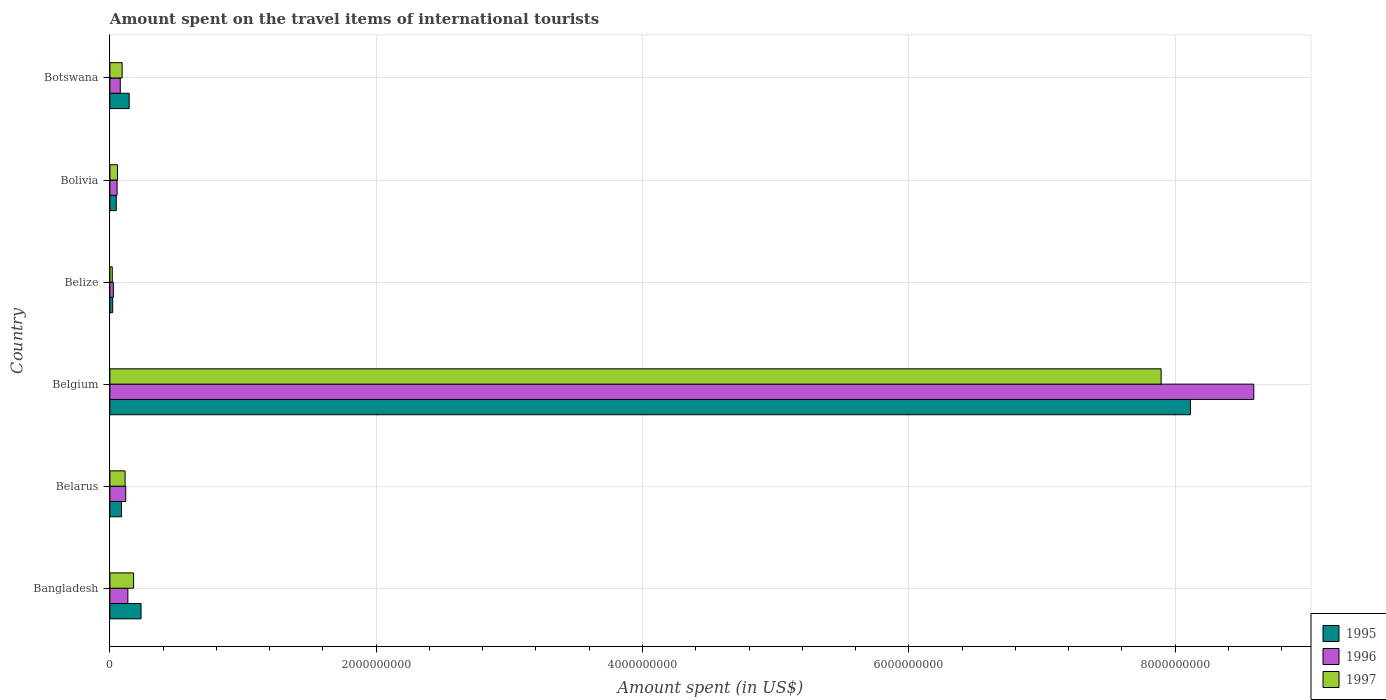How many groups of bars are there?
Your answer should be compact. 6. How many bars are there on the 3rd tick from the bottom?
Make the answer very short. 3. What is the amount spent on the travel items of international tourists in 1996 in Bangladesh?
Provide a succinct answer. 1.35e+08. Across all countries, what is the maximum amount spent on the travel items of international tourists in 1996?
Offer a terse response. 8.59e+09. Across all countries, what is the minimum amount spent on the travel items of international tourists in 1995?
Offer a very short reply. 2.10e+07. In which country was the amount spent on the travel items of international tourists in 1995 minimum?
Keep it short and to the point. Belize. What is the total amount spent on the travel items of international tourists in 1996 in the graph?
Keep it short and to the point. 9.00e+09. What is the difference between the amount spent on the travel items of international tourists in 1995 in Bangladesh and that in Botswana?
Your response must be concise. 8.90e+07. What is the difference between the amount spent on the travel items of international tourists in 1996 in Bangladesh and the amount spent on the travel items of international tourists in 1995 in Belarus?
Give a very brief answer. 4.80e+07. What is the average amount spent on the travel items of international tourists in 1996 per country?
Your response must be concise. 1.50e+09. What is the difference between the amount spent on the travel items of international tourists in 1997 and amount spent on the travel items of international tourists in 1996 in Bangladesh?
Ensure brevity in your answer.  4.30e+07. In how many countries, is the amount spent on the travel items of international tourists in 1996 greater than 5200000000 US$?
Your answer should be very brief. 1. What is the ratio of the amount spent on the travel items of international tourists in 1997 in Belarus to that in Botswana?
Give a very brief answer. 1.24. Is the amount spent on the travel items of international tourists in 1997 in Belarus less than that in Botswana?
Ensure brevity in your answer.  No. What is the difference between the highest and the second highest amount spent on the travel items of international tourists in 1995?
Give a very brief answer. 7.88e+09. What is the difference between the highest and the lowest amount spent on the travel items of international tourists in 1995?
Your response must be concise. 8.09e+09. Is it the case that in every country, the sum of the amount spent on the travel items of international tourists in 1996 and amount spent on the travel items of international tourists in 1997 is greater than the amount spent on the travel items of international tourists in 1995?
Your answer should be compact. Yes. Are the values on the major ticks of X-axis written in scientific E-notation?
Offer a terse response. No. How many legend labels are there?
Keep it short and to the point. 3. What is the title of the graph?
Your answer should be compact. Amount spent on the travel items of international tourists. Does "1971" appear as one of the legend labels in the graph?
Your answer should be compact. No. What is the label or title of the X-axis?
Your answer should be very brief. Amount spent (in US$). What is the Amount spent (in US$) in 1995 in Bangladesh?
Your response must be concise. 2.34e+08. What is the Amount spent (in US$) in 1996 in Bangladesh?
Provide a short and direct response. 1.35e+08. What is the Amount spent (in US$) of 1997 in Bangladesh?
Offer a very short reply. 1.78e+08. What is the Amount spent (in US$) in 1995 in Belarus?
Make the answer very short. 8.70e+07. What is the Amount spent (in US$) of 1996 in Belarus?
Offer a terse response. 1.19e+08. What is the Amount spent (in US$) in 1997 in Belarus?
Make the answer very short. 1.14e+08. What is the Amount spent (in US$) in 1995 in Belgium?
Your answer should be very brief. 8.12e+09. What is the Amount spent (in US$) of 1996 in Belgium?
Your answer should be compact. 8.59e+09. What is the Amount spent (in US$) in 1997 in Belgium?
Provide a short and direct response. 7.90e+09. What is the Amount spent (in US$) in 1995 in Belize?
Make the answer very short. 2.10e+07. What is the Amount spent (in US$) of 1996 in Belize?
Your answer should be very brief. 2.60e+07. What is the Amount spent (in US$) in 1997 in Belize?
Your response must be concise. 1.80e+07. What is the Amount spent (in US$) in 1995 in Bolivia?
Offer a very short reply. 4.80e+07. What is the Amount spent (in US$) of 1996 in Bolivia?
Offer a very short reply. 5.40e+07. What is the Amount spent (in US$) of 1997 in Bolivia?
Your answer should be very brief. 5.70e+07. What is the Amount spent (in US$) in 1995 in Botswana?
Offer a terse response. 1.45e+08. What is the Amount spent (in US$) in 1996 in Botswana?
Give a very brief answer. 7.80e+07. What is the Amount spent (in US$) of 1997 in Botswana?
Your answer should be very brief. 9.20e+07. Across all countries, what is the maximum Amount spent (in US$) of 1995?
Your answer should be compact. 8.12e+09. Across all countries, what is the maximum Amount spent (in US$) of 1996?
Ensure brevity in your answer.  8.59e+09. Across all countries, what is the maximum Amount spent (in US$) of 1997?
Offer a terse response. 7.90e+09. Across all countries, what is the minimum Amount spent (in US$) of 1995?
Make the answer very short. 2.10e+07. Across all countries, what is the minimum Amount spent (in US$) in 1996?
Make the answer very short. 2.60e+07. Across all countries, what is the minimum Amount spent (in US$) in 1997?
Ensure brevity in your answer.  1.80e+07. What is the total Amount spent (in US$) in 1995 in the graph?
Provide a short and direct response. 8.65e+09. What is the total Amount spent (in US$) in 1996 in the graph?
Offer a terse response. 9.00e+09. What is the total Amount spent (in US$) of 1997 in the graph?
Your answer should be very brief. 8.35e+09. What is the difference between the Amount spent (in US$) of 1995 in Bangladesh and that in Belarus?
Give a very brief answer. 1.47e+08. What is the difference between the Amount spent (in US$) in 1996 in Bangladesh and that in Belarus?
Provide a short and direct response. 1.60e+07. What is the difference between the Amount spent (in US$) in 1997 in Bangladesh and that in Belarus?
Make the answer very short. 6.40e+07. What is the difference between the Amount spent (in US$) of 1995 in Bangladesh and that in Belgium?
Your answer should be very brief. -7.88e+09. What is the difference between the Amount spent (in US$) in 1996 in Bangladesh and that in Belgium?
Offer a terse response. -8.46e+09. What is the difference between the Amount spent (in US$) in 1997 in Bangladesh and that in Belgium?
Ensure brevity in your answer.  -7.72e+09. What is the difference between the Amount spent (in US$) of 1995 in Bangladesh and that in Belize?
Your answer should be compact. 2.13e+08. What is the difference between the Amount spent (in US$) in 1996 in Bangladesh and that in Belize?
Your answer should be compact. 1.09e+08. What is the difference between the Amount spent (in US$) in 1997 in Bangladesh and that in Belize?
Your answer should be compact. 1.60e+08. What is the difference between the Amount spent (in US$) of 1995 in Bangladesh and that in Bolivia?
Make the answer very short. 1.86e+08. What is the difference between the Amount spent (in US$) of 1996 in Bangladesh and that in Bolivia?
Offer a very short reply. 8.10e+07. What is the difference between the Amount spent (in US$) of 1997 in Bangladesh and that in Bolivia?
Keep it short and to the point. 1.21e+08. What is the difference between the Amount spent (in US$) in 1995 in Bangladesh and that in Botswana?
Your answer should be very brief. 8.90e+07. What is the difference between the Amount spent (in US$) of 1996 in Bangladesh and that in Botswana?
Give a very brief answer. 5.70e+07. What is the difference between the Amount spent (in US$) in 1997 in Bangladesh and that in Botswana?
Offer a very short reply. 8.60e+07. What is the difference between the Amount spent (in US$) of 1995 in Belarus and that in Belgium?
Offer a terse response. -8.03e+09. What is the difference between the Amount spent (in US$) in 1996 in Belarus and that in Belgium?
Provide a short and direct response. -8.47e+09. What is the difference between the Amount spent (in US$) of 1997 in Belarus and that in Belgium?
Keep it short and to the point. -7.78e+09. What is the difference between the Amount spent (in US$) of 1995 in Belarus and that in Belize?
Offer a terse response. 6.60e+07. What is the difference between the Amount spent (in US$) of 1996 in Belarus and that in Belize?
Give a very brief answer. 9.30e+07. What is the difference between the Amount spent (in US$) in 1997 in Belarus and that in Belize?
Provide a short and direct response. 9.60e+07. What is the difference between the Amount spent (in US$) in 1995 in Belarus and that in Bolivia?
Ensure brevity in your answer.  3.90e+07. What is the difference between the Amount spent (in US$) in 1996 in Belarus and that in Bolivia?
Your response must be concise. 6.50e+07. What is the difference between the Amount spent (in US$) in 1997 in Belarus and that in Bolivia?
Ensure brevity in your answer.  5.70e+07. What is the difference between the Amount spent (in US$) in 1995 in Belarus and that in Botswana?
Your answer should be compact. -5.80e+07. What is the difference between the Amount spent (in US$) in 1996 in Belarus and that in Botswana?
Your answer should be very brief. 4.10e+07. What is the difference between the Amount spent (in US$) in 1997 in Belarus and that in Botswana?
Offer a very short reply. 2.20e+07. What is the difference between the Amount spent (in US$) in 1995 in Belgium and that in Belize?
Offer a terse response. 8.09e+09. What is the difference between the Amount spent (in US$) of 1996 in Belgium and that in Belize?
Ensure brevity in your answer.  8.56e+09. What is the difference between the Amount spent (in US$) in 1997 in Belgium and that in Belize?
Your answer should be compact. 7.88e+09. What is the difference between the Amount spent (in US$) of 1995 in Belgium and that in Bolivia?
Give a very brief answer. 8.07e+09. What is the difference between the Amount spent (in US$) of 1996 in Belgium and that in Bolivia?
Keep it short and to the point. 8.54e+09. What is the difference between the Amount spent (in US$) in 1997 in Belgium and that in Bolivia?
Ensure brevity in your answer.  7.84e+09. What is the difference between the Amount spent (in US$) of 1995 in Belgium and that in Botswana?
Ensure brevity in your answer.  7.97e+09. What is the difference between the Amount spent (in US$) of 1996 in Belgium and that in Botswana?
Ensure brevity in your answer.  8.51e+09. What is the difference between the Amount spent (in US$) of 1997 in Belgium and that in Botswana?
Give a very brief answer. 7.80e+09. What is the difference between the Amount spent (in US$) of 1995 in Belize and that in Bolivia?
Offer a terse response. -2.70e+07. What is the difference between the Amount spent (in US$) in 1996 in Belize and that in Bolivia?
Keep it short and to the point. -2.80e+07. What is the difference between the Amount spent (in US$) of 1997 in Belize and that in Bolivia?
Your response must be concise. -3.90e+07. What is the difference between the Amount spent (in US$) of 1995 in Belize and that in Botswana?
Make the answer very short. -1.24e+08. What is the difference between the Amount spent (in US$) in 1996 in Belize and that in Botswana?
Offer a terse response. -5.20e+07. What is the difference between the Amount spent (in US$) of 1997 in Belize and that in Botswana?
Offer a terse response. -7.40e+07. What is the difference between the Amount spent (in US$) of 1995 in Bolivia and that in Botswana?
Offer a terse response. -9.70e+07. What is the difference between the Amount spent (in US$) of 1996 in Bolivia and that in Botswana?
Make the answer very short. -2.40e+07. What is the difference between the Amount spent (in US$) of 1997 in Bolivia and that in Botswana?
Keep it short and to the point. -3.50e+07. What is the difference between the Amount spent (in US$) of 1995 in Bangladesh and the Amount spent (in US$) of 1996 in Belarus?
Provide a succinct answer. 1.15e+08. What is the difference between the Amount spent (in US$) of 1995 in Bangladesh and the Amount spent (in US$) of 1997 in Belarus?
Make the answer very short. 1.20e+08. What is the difference between the Amount spent (in US$) of 1996 in Bangladesh and the Amount spent (in US$) of 1997 in Belarus?
Give a very brief answer. 2.10e+07. What is the difference between the Amount spent (in US$) in 1995 in Bangladesh and the Amount spent (in US$) in 1996 in Belgium?
Make the answer very short. -8.36e+09. What is the difference between the Amount spent (in US$) of 1995 in Bangladesh and the Amount spent (in US$) of 1997 in Belgium?
Your answer should be very brief. -7.66e+09. What is the difference between the Amount spent (in US$) of 1996 in Bangladesh and the Amount spent (in US$) of 1997 in Belgium?
Provide a short and direct response. -7.76e+09. What is the difference between the Amount spent (in US$) of 1995 in Bangladesh and the Amount spent (in US$) of 1996 in Belize?
Give a very brief answer. 2.08e+08. What is the difference between the Amount spent (in US$) in 1995 in Bangladesh and the Amount spent (in US$) in 1997 in Belize?
Ensure brevity in your answer.  2.16e+08. What is the difference between the Amount spent (in US$) of 1996 in Bangladesh and the Amount spent (in US$) of 1997 in Belize?
Provide a succinct answer. 1.17e+08. What is the difference between the Amount spent (in US$) in 1995 in Bangladesh and the Amount spent (in US$) in 1996 in Bolivia?
Your answer should be very brief. 1.80e+08. What is the difference between the Amount spent (in US$) of 1995 in Bangladesh and the Amount spent (in US$) of 1997 in Bolivia?
Your response must be concise. 1.77e+08. What is the difference between the Amount spent (in US$) in 1996 in Bangladesh and the Amount spent (in US$) in 1997 in Bolivia?
Ensure brevity in your answer.  7.80e+07. What is the difference between the Amount spent (in US$) in 1995 in Bangladesh and the Amount spent (in US$) in 1996 in Botswana?
Provide a short and direct response. 1.56e+08. What is the difference between the Amount spent (in US$) of 1995 in Bangladesh and the Amount spent (in US$) of 1997 in Botswana?
Provide a short and direct response. 1.42e+08. What is the difference between the Amount spent (in US$) in 1996 in Bangladesh and the Amount spent (in US$) in 1997 in Botswana?
Your answer should be compact. 4.30e+07. What is the difference between the Amount spent (in US$) of 1995 in Belarus and the Amount spent (in US$) of 1996 in Belgium?
Make the answer very short. -8.50e+09. What is the difference between the Amount spent (in US$) in 1995 in Belarus and the Amount spent (in US$) in 1997 in Belgium?
Provide a succinct answer. -7.81e+09. What is the difference between the Amount spent (in US$) of 1996 in Belarus and the Amount spent (in US$) of 1997 in Belgium?
Your answer should be very brief. -7.78e+09. What is the difference between the Amount spent (in US$) in 1995 in Belarus and the Amount spent (in US$) in 1996 in Belize?
Your answer should be compact. 6.10e+07. What is the difference between the Amount spent (in US$) of 1995 in Belarus and the Amount spent (in US$) of 1997 in Belize?
Offer a very short reply. 6.90e+07. What is the difference between the Amount spent (in US$) in 1996 in Belarus and the Amount spent (in US$) in 1997 in Belize?
Your answer should be very brief. 1.01e+08. What is the difference between the Amount spent (in US$) in 1995 in Belarus and the Amount spent (in US$) in 1996 in Bolivia?
Make the answer very short. 3.30e+07. What is the difference between the Amount spent (in US$) of 1995 in Belarus and the Amount spent (in US$) of 1997 in Bolivia?
Your answer should be very brief. 3.00e+07. What is the difference between the Amount spent (in US$) in 1996 in Belarus and the Amount spent (in US$) in 1997 in Bolivia?
Your answer should be compact. 6.20e+07. What is the difference between the Amount spent (in US$) in 1995 in Belarus and the Amount spent (in US$) in 1996 in Botswana?
Offer a terse response. 9.00e+06. What is the difference between the Amount spent (in US$) of 1995 in Belarus and the Amount spent (in US$) of 1997 in Botswana?
Provide a succinct answer. -5.00e+06. What is the difference between the Amount spent (in US$) of 1996 in Belarus and the Amount spent (in US$) of 1997 in Botswana?
Keep it short and to the point. 2.70e+07. What is the difference between the Amount spent (in US$) of 1995 in Belgium and the Amount spent (in US$) of 1996 in Belize?
Offer a very short reply. 8.09e+09. What is the difference between the Amount spent (in US$) of 1995 in Belgium and the Amount spent (in US$) of 1997 in Belize?
Make the answer very short. 8.10e+09. What is the difference between the Amount spent (in US$) of 1996 in Belgium and the Amount spent (in US$) of 1997 in Belize?
Your response must be concise. 8.57e+09. What is the difference between the Amount spent (in US$) of 1995 in Belgium and the Amount spent (in US$) of 1996 in Bolivia?
Offer a terse response. 8.06e+09. What is the difference between the Amount spent (in US$) of 1995 in Belgium and the Amount spent (in US$) of 1997 in Bolivia?
Make the answer very short. 8.06e+09. What is the difference between the Amount spent (in US$) of 1996 in Belgium and the Amount spent (in US$) of 1997 in Bolivia?
Keep it short and to the point. 8.53e+09. What is the difference between the Amount spent (in US$) in 1995 in Belgium and the Amount spent (in US$) in 1996 in Botswana?
Your answer should be compact. 8.04e+09. What is the difference between the Amount spent (in US$) of 1995 in Belgium and the Amount spent (in US$) of 1997 in Botswana?
Keep it short and to the point. 8.02e+09. What is the difference between the Amount spent (in US$) in 1996 in Belgium and the Amount spent (in US$) in 1997 in Botswana?
Your response must be concise. 8.50e+09. What is the difference between the Amount spent (in US$) of 1995 in Belize and the Amount spent (in US$) of 1996 in Bolivia?
Offer a very short reply. -3.30e+07. What is the difference between the Amount spent (in US$) in 1995 in Belize and the Amount spent (in US$) in 1997 in Bolivia?
Provide a short and direct response. -3.60e+07. What is the difference between the Amount spent (in US$) of 1996 in Belize and the Amount spent (in US$) of 1997 in Bolivia?
Provide a succinct answer. -3.10e+07. What is the difference between the Amount spent (in US$) of 1995 in Belize and the Amount spent (in US$) of 1996 in Botswana?
Your answer should be very brief. -5.70e+07. What is the difference between the Amount spent (in US$) in 1995 in Belize and the Amount spent (in US$) in 1997 in Botswana?
Offer a very short reply. -7.10e+07. What is the difference between the Amount spent (in US$) in 1996 in Belize and the Amount spent (in US$) in 1997 in Botswana?
Your answer should be compact. -6.60e+07. What is the difference between the Amount spent (in US$) of 1995 in Bolivia and the Amount spent (in US$) of 1996 in Botswana?
Your answer should be compact. -3.00e+07. What is the difference between the Amount spent (in US$) of 1995 in Bolivia and the Amount spent (in US$) of 1997 in Botswana?
Provide a succinct answer. -4.40e+07. What is the difference between the Amount spent (in US$) in 1996 in Bolivia and the Amount spent (in US$) in 1997 in Botswana?
Offer a terse response. -3.80e+07. What is the average Amount spent (in US$) in 1995 per country?
Your response must be concise. 1.44e+09. What is the average Amount spent (in US$) of 1996 per country?
Make the answer very short. 1.50e+09. What is the average Amount spent (in US$) in 1997 per country?
Give a very brief answer. 1.39e+09. What is the difference between the Amount spent (in US$) in 1995 and Amount spent (in US$) in 1996 in Bangladesh?
Ensure brevity in your answer.  9.90e+07. What is the difference between the Amount spent (in US$) of 1995 and Amount spent (in US$) of 1997 in Bangladesh?
Provide a short and direct response. 5.60e+07. What is the difference between the Amount spent (in US$) in 1996 and Amount spent (in US$) in 1997 in Bangladesh?
Your answer should be compact. -4.30e+07. What is the difference between the Amount spent (in US$) of 1995 and Amount spent (in US$) of 1996 in Belarus?
Your answer should be very brief. -3.20e+07. What is the difference between the Amount spent (in US$) of 1995 and Amount spent (in US$) of 1997 in Belarus?
Ensure brevity in your answer.  -2.70e+07. What is the difference between the Amount spent (in US$) in 1995 and Amount spent (in US$) in 1996 in Belgium?
Provide a succinct answer. -4.76e+08. What is the difference between the Amount spent (in US$) of 1995 and Amount spent (in US$) of 1997 in Belgium?
Provide a succinct answer. 2.20e+08. What is the difference between the Amount spent (in US$) of 1996 and Amount spent (in US$) of 1997 in Belgium?
Keep it short and to the point. 6.96e+08. What is the difference between the Amount spent (in US$) of 1995 and Amount spent (in US$) of 1996 in Belize?
Ensure brevity in your answer.  -5.00e+06. What is the difference between the Amount spent (in US$) in 1995 and Amount spent (in US$) in 1997 in Belize?
Your answer should be compact. 3.00e+06. What is the difference between the Amount spent (in US$) of 1995 and Amount spent (in US$) of 1996 in Bolivia?
Provide a short and direct response. -6.00e+06. What is the difference between the Amount spent (in US$) in 1995 and Amount spent (in US$) in 1997 in Bolivia?
Give a very brief answer. -9.00e+06. What is the difference between the Amount spent (in US$) in 1995 and Amount spent (in US$) in 1996 in Botswana?
Offer a very short reply. 6.70e+07. What is the difference between the Amount spent (in US$) in 1995 and Amount spent (in US$) in 1997 in Botswana?
Make the answer very short. 5.30e+07. What is the difference between the Amount spent (in US$) in 1996 and Amount spent (in US$) in 1997 in Botswana?
Your response must be concise. -1.40e+07. What is the ratio of the Amount spent (in US$) in 1995 in Bangladesh to that in Belarus?
Provide a succinct answer. 2.69. What is the ratio of the Amount spent (in US$) of 1996 in Bangladesh to that in Belarus?
Your answer should be compact. 1.13. What is the ratio of the Amount spent (in US$) of 1997 in Bangladesh to that in Belarus?
Make the answer very short. 1.56. What is the ratio of the Amount spent (in US$) in 1995 in Bangladesh to that in Belgium?
Offer a terse response. 0.03. What is the ratio of the Amount spent (in US$) of 1996 in Bangladesh to that in Belgium?
Make the answer very short. 0.02. What is the ratio of the Amount spent (in US$) in 1997 in Bangladesh to that in Belgium?
Your answer should be compact. 0.02. What is the ratio of the Amount spent (in US$) of 1995 in Bangladesh to that in Belize?
Your answer should be very brief. 11.14. What is the ratio of the Amount spent (in US$) in 1996 in Bangladesh to that in Belize?
Your answer should be compact. 5.19. What is the ratio of the Amount spent (in US$) of 1997 in Bangladesh to that in Belize?
Ensure brevity in your answer.  9.89. What is the ratio of the Amount spent (in US$) in 1995 in Bangladesh to that in Bolivia?
Provide a succinct answer. 4.88. What is the ratio of the Amount spent (in US$) in 1997 in Bangladesh to that in Bolivia?
Your answer should be very brief. 3.12. What is the ratio of the Amount spent (in US$) of 1995 in Bangladesh to that in Botswana?
Offer a terse response. 1.61. What is the ratio of the Amount spent (in US$) in 1996 in Bangladesh to that in Botswana?
Ensure brevity in your answer.  1.73. What is the ratio of the Amount spent (in US$) in 1997 in Bangladesh to that in Botswana?
Make the answer very short. 1.93. What is the ratio of the Amount spent (in US$) in 1995 in Belarus to that in Belgium?
Provide a short and direct response. 0.01. What is the ratio of the Amount spent (in US$) in 1996 in Belarus to that in Belgium?
Offer a very short reply. 0.01. What is the ratio of the Amount spent (in US$) of 1997 in Belarus to that in Belgium?
Provide a short and direct response. 0.01. What is the ratio of the Amount spent (in US$) of 1995 in Belarus to that in Belize?
Give a very brief answer. 4.14. What is the ratio of the Amount spent (in US$) in 1996 in Belarus to that in Belize?
Give a very brief answer. 4.58. What is the ratio of the Amount spent (in US$) of 1997 in Belarus to that in Belize?
Your response must be concise. 6.33. What is the ratio of the Amount spent (in US$) in 1995 in Belarus to that in Bolivia?
Keep it short and to the point. 1.81. What is the ratio of the Amount spent (in US$) in 1996 in Belarus to that in Bolivia?
Offer a very short reply. 2.2. What is the ratio of the Amount spent (in US$) of 1995 in Belarus to that in Botswana?
Your response must be concise. 0.6. What is the ratio of the Amount spent (in US$) of 1996 in Belarus to that in Botswana?
Ensure brevity in your answer.  1.53. What is the ratio of the Amount spent (in US$) in 1997 in Belarus to that in Botswana?
Provide a succinct answer. 1.24. What is the ratio of the Amount spent (in US$) of 1995 in Belgium to that in Belize?
Ensure brevity in your answer.  386.43. What is the ratio of the Amount spent (in US$) in 1996 in Belgium to that in Belize?
Ensure brevity in your answer.  330.42. What is the ratio of the Amount spent (in US$) of 1997 in Belgium to that in Belize?
Offer a terse response. 438.61. What is the ratio of the Amount spent (in US$) of 1995 in Belgium to that in Bolivia?
Make the answer very short. 169.06. What is the ratio of the Amount spent (in US$) of 1996 in Belgium to that in Bolivia?
Your answer should be compact. 159.09. What is the ratio of the Amount spent (in US$) of 1997 in Belgium to that in Bolivia?
Ensure brevity in your answer.  138.51. What is the ratio of the Amount spent (in US$) of 1995 in Belgium to that in Botswana?
Make the answer very short. 55.97. What is the ratio of the Amount spent (in US$) in 1996 in Belgium to that in Botswana?
Provide a succinct answer. 110.14. What is the ratio of the Amount spent (in US$) in 1997 in Belgium to that in Botswana?
Offer a terse response. 85.82. What is the ratio of the Amount spent (in US$) of 1995 in Belize to that in Bolivia?
Keep it short and to the point. 0.44. What is the ratio of the Amount spent (in US$) in 1996 in Belize to that in Bolivia?
Your response must be concise. 0.48. What is the ratio of the Amount spent (in US$) of 1997 in Belize to that in Bolivia?
Provide a succinct answer. 0.32. What is the ratio of the Amount spent (in US$) in 1995 in Belize to that in Botswana?
Give a very brief answer. 0.14. What is the ratio of the Amount spent (in US$) in 1997 in Belize to that in Botswana?
Your answer should be compact. 0.2. What is the ratio of the Amount spent (in US$) of 1995 in Bolivia to that in Botswana?
Your answer should be compact. 0.33. What is the ratio of the Amount spent (in US$) in 1996 in Bolivia to that in Botswana?
Keep it short and to the point. 0.69. What is the ratio of the Amount spent (in US$) of 1997 in Bolivia to that in Botswana?
Make the answer very short. 0.62. What is the difference between the highest and the second highest Amount spent (in US$) in 1995?
Provide a succinct answer. 7.88e+09. What is the difference between the highest and the second highest Amount spent (in US$) of 1996?
Your response must be concise. 8.46e+09. What is the difference between the highest and the second highest Amount spent (in US$) in 1997?
Provide a short and direct response. 7.72e+09. What is the difference between the highest and the lowest Amount spent (in US$) of 1995?
Your answer should be compact. 8.09e+09. What is the difference between the highest and the lowest Amount spent (in US$) in 1996?
Your answer should be very brief. 8.56e+09. What is the difference between the highest and the lowest Amount spent (in US$) of 1997?
Offer a very short reply. 7.88e+09. 